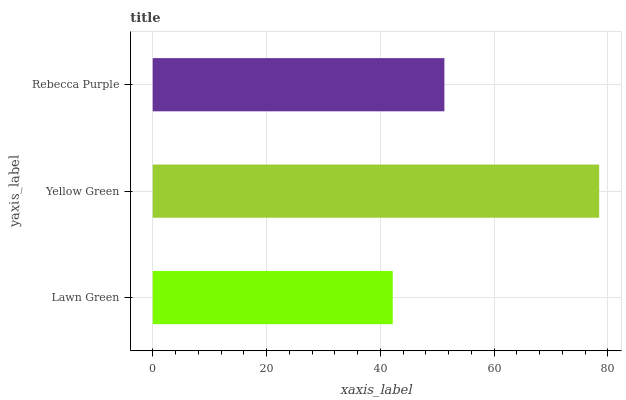Is Lawn Green the minimum?
Answer yes or no. Yes. Is Yellow Green the maximum?
Answer yes or no. Yes. Is Rebecca Purple the minimum?
Answer yes or no. No. Is Rebecca Purple the maximum?
Answer yes or no. No. Is Yellow Green greater than Rebecca Purple?
Answer yes or no. Yes. Is Rebecca Purple less than Yellow Green?
Answer yes or no. Yes. Is Rebecca Purple greater than Yellow Green?
Answer yes or no. No. Is Yellow Green less than Rebecca Purple?
Answer yes or no. No. Is Rebecca Purple the high median?
Answer yes or no. Yes. Is Rebecca Purple the low median?
Answer yes or no. Yes. Is Lawn Green the high median?
Answer yes or no. No. Is Lawn Green the low median?
Answer yes or no. No. 